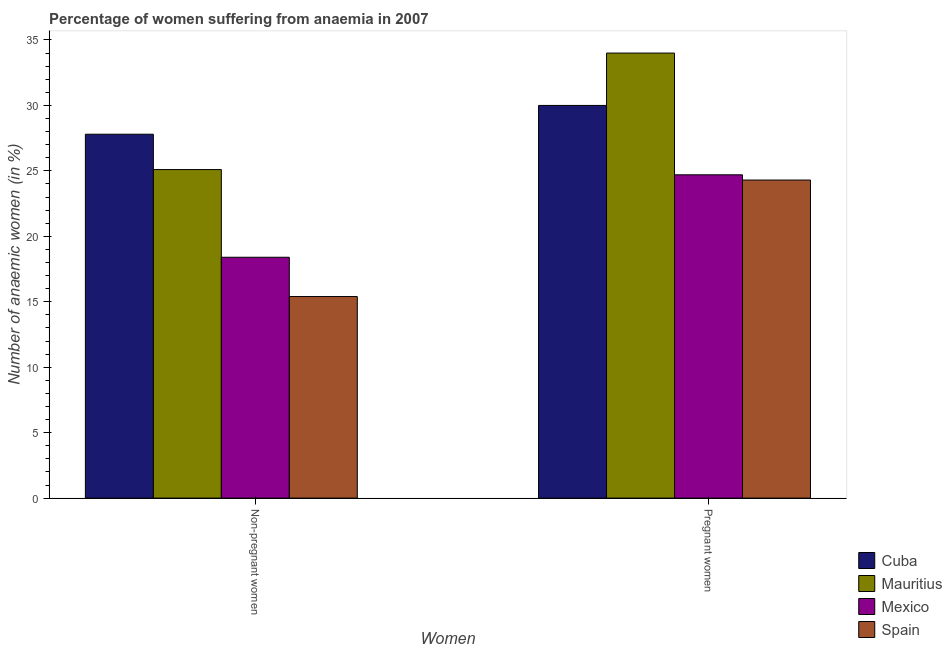How many different coloured bars are there?
Your answer should be compact. 4. How many groups of bars are there?
Offer a very short reply. 2. Are the number of bars on each tick of the X-axis equal?
Your response must be concise. Yes. How many bars are there on the 1st tick from the right?
Your answer should be compact. 4. What is the label of the 1st group of bars from the left?
Provide a succinct answer. Non-pregnant women. What is the percentage of pregnant anaemic women in Cuba?
Give a very brief answer. 30. Across all countries, what is the maximum percentage of pregnant anaemic women?
Keep it short and to the point. 34. Across all countries, what is the minimum percentage of non-pregnant anaemic women?
Keep it short and to the point. 15.4. In which country was the percentage of pregnant anaemic women maximum?
Keep it short and to the point. Mauritius. What is the total percentage of non-pregnant anaemic women in the graph?
Give a very brief answer. 86.7. What is the difference between the percentage of non-pregnant anaemic women in Mauritius and that in Cuba?
Keep it short and to the point. -2.7. What is the difference between the percentage of pregnant anaemic women in Mauritius and the percentage of non-pregnant anaemic women in Cuba?
Give a very brief answer. 6.2. What is the average percentage of non-pregnant anaemic women per country?
Keep it short and to the point. 21.68. What is the difference between the percentage of non-pregnant anaemic women and percentage of pregnant anaemic women in Spain?
Offer a very short reply. -8.9. What is the ratio of the percentage of non-pregnant anaemic women in Spain to that in Cuba?
Your answer should be compact. 0.55. What does the 4th bar from the left in Pregnant women represents?
Give a very brief answer. Spain. Are the values on the major ticks of Y-axis written in scientific E-notation?
Provide a short and direct response. No. Where does the legend appear in the graph?
Provide a short and direct response. Bottom right. How are the legend labels stacked?
Your answer should be very brief. Vertical. What is the title of the graph?
Your answer should be very brief. Percentage of women suffering from anaemia in 2007. Does "Sierra Leone" appear as one of the legend labels in the graph?
Your answer should be very brief. No. What is the label or title of the X-axis?
Offer a terse response. Women. What is the label or title of the Y-axis?
Offer a terse response. Number of anaemic women (in %). What is the Number of anaemic women (in %) in Cuba in Non-pregnant women?
Your answer should be compact. 27.8. What is the Number of anaemic women (in %) in Mauritius in Non-pregnant women?
Offer a terse response. 25.1. What is the Number of anaemic women (in %) in Mexico in Pregnant women?
Make the answer very short. 24.7. What is the Number of anaemic women (in %) in Spain in Pregnant women?
Your answer should be very brief. 24.3. Across all Women, what is the maximum Number of anaemic women (in %) in Cuba?
Provide a succinct answer. 30. Across all Women, what is the maximum Number of anaemic women (in %) in Mexico?
Make the answer very short. 24.7. Across all Women, what is the maximum Number of anaemic women (in %) of Spain?
Offer a very short reply. 24.3. Across all Women, what is the minimum Number of anaemic women (in %) in Cuba?
Your response must be concise. 27.8. Across all Women, what is the minimum Number of anaemic women (in %) of Mauritius?
Provide a short and direct response. 25.1. Across all Women, what is the minimum Number of anaemic women (in %) in Mexico?
Your answer should be compact. 18.4. Across all Women, what is the minimum Number of anaemic women (in %) in Spain?
Your response must be concise. 15.4. What is the total Number of anaemic women (in %) in Cuba in the graph?
Keep it short and to the point. 57.8. What is the total Number of anaemic women (in %) of Mauritius in the graph?
Your answer should be very brief. 59.1. What is the total Number of anaemic women (in %) of Mexico in the graph?
Keep it short and to the point. 43.1. What is the total Number of anaemic women (in %) in Spain in the graph?
Offer a terse response. 39.7. What is the difference between the Number of anaemic women (in %) in Cuba in Non-pregnant women and the Number of anaemic women (in %) in Mexico in Pregnant women?
Provide a succinct answer. 3.1. What is the difference between the Number of anaemic women (in %) in Cuba in Non-pregnant women and the Number of anaemic women (in %) in Spain in Pregnant women?
Ensure brevity in your answer.  3.5. What is the difference between the Number of anaemic women (in %) in Mauritius in Non-pregnant women and the Number of anaemic women (in %) in Spain in Pregnant women?
Make the answer very short. 0.8. What is the average Number of anaemic women (in %) in Cuba per Women?
Provide a short and direct response. 28.9. What is the average Number of anaemic women (in %) in Mauritius per Women?
Keep it short and to the point. 29.55. What is the average Number of anaemic women (in %) in Mexico per Women?
Keep it short and to the point. 21.55. What is the average Number of anaemic women (in %) of Spain per Women?
Give a very brief answer. 19.85. What is the difference between the Number of anaemic women (in %) in Cuba and Number of anaemic women (in %) in Mauritius in Non-pregnant women?
Your answer should be compact. 2.7. What is the difference between the Number of anaemic women (in %) of Cuba and Number of anaemic women (in %) of Mexico in Non-pregnant women?
Offer a very short reply. 9.4. What is the difference between the Number of anaemic women (in %) in Cuba and Number of anaemic women (in %) in Spain in Non-pregnant women?
Offer a very short reply. 12.4. What is the difference between the Number of anaemic women (in %) in Mauritius and Number of anaemic women (in %) in Mexico in Non-pregnant women?
Offer a terse response. 6.7. What is the difference between the Number of anaemic women (in %) of Mauritius and Number of anaemic women (in %) of Spain in Non-pregnant women?
Make the answer very short. 9.7. What is the difference between the Number of anaemic women (in %) in Mexico and Number of anaemic women (in %) in Spain in Non-pregnant women?
Keep it short and to the point. 3. What is the difference between the Number of anaemic women (in %) in Cuba and Number of anaemic women (in %) in Mauritius in Pregnant women?
Offer a terse response. -4. What is the difference between the Number of anaemic women (in %) in Cuba and Number of anaemic women (in %) in Spain in Pregnant women?
Your response must be concise. 5.7. What is the difference between the Number of anaemic women (in %) in Mauritius and Number of anaemic women (in %) in Mexico in Pregnant women?
Ensure brevity in your answer.  9.3. What is the difference between the Number of anaemic women (in %) in Mexico and Number of anaemic women (in %) in Spain in Pregnant women?
Your response must be concise. 0.4. What is the ratio of the Number of anaemic women (in %) in Cuba in Non-pregnant women to that in Pregnant women?
Your answer should be compact. 0.93. What is the ratio of the Number of anaemic women (in %) of Mauritius in Non-pregnant women to that in Pregnant women?
Your answer should be very brief. 0.74. What is the ratio of the Number of anaemic women (in %) in Mexico in Non-pregnant women to that in Pregnant women?
Provide a short and direct response. 0.74. What is the ratio of the Number of anaemic women (in %) of Spain in Non-pregnant women to that in Pregnant women?
Make the answer very short. 0.63. What is the difference between the highest and the second highest Number of anaemic women (in %) of Mauritius?
Ensure brevity in your answer.  8.9. What is the difference between the highest and the second highest Number of anaemic women (in %) of Mexico?
Ensure brevity in your answer.  6.3. What is the difference between the highest and the second highest Number of anaemic women (in %) of Spain?
Your response must be concise. 8.9. What is the difference between the highest and the lowest Number of anaemic women (in %) in Mauritius?
Your answer should be very brief. 8.9. What is the difference between the highest and the lowest Number of anaemic women (in %) of Mexico?
Keep it short and to the point. 6.3. What is the difference between the highest and the lowest Number of anaemic women (in %) in Spain?
Give a very brief answer. 8.9. 